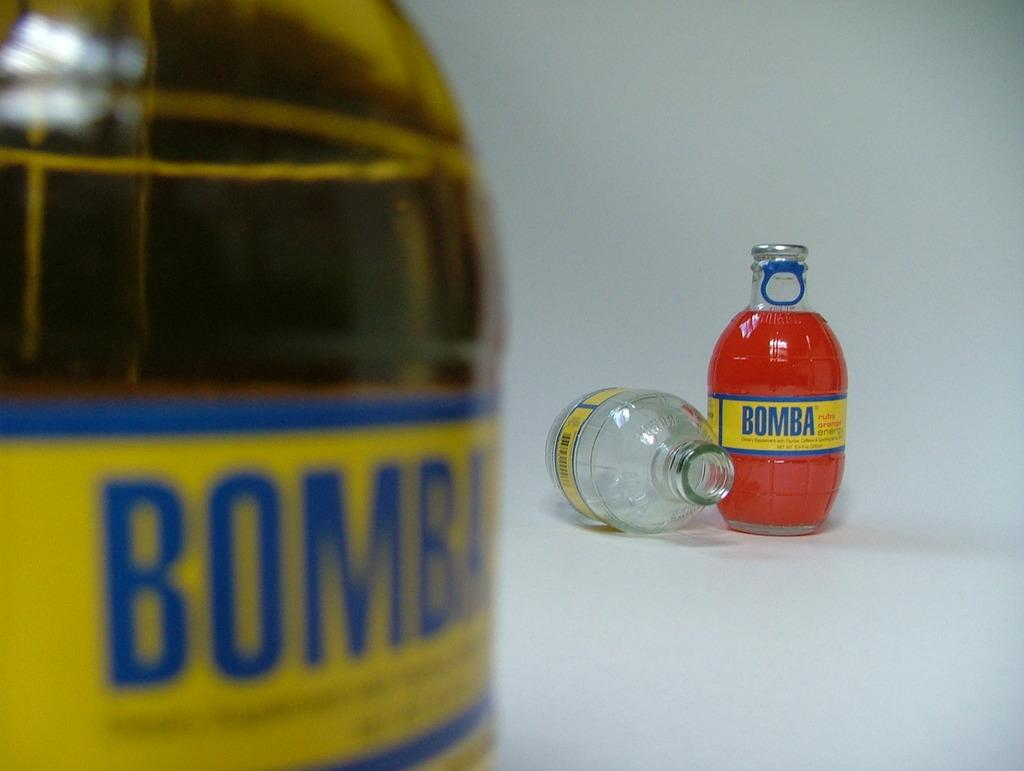<image>
Summarize the visual content of the image. Several bottles of liquid, one of the empty, but all with the brand name Bomba. 